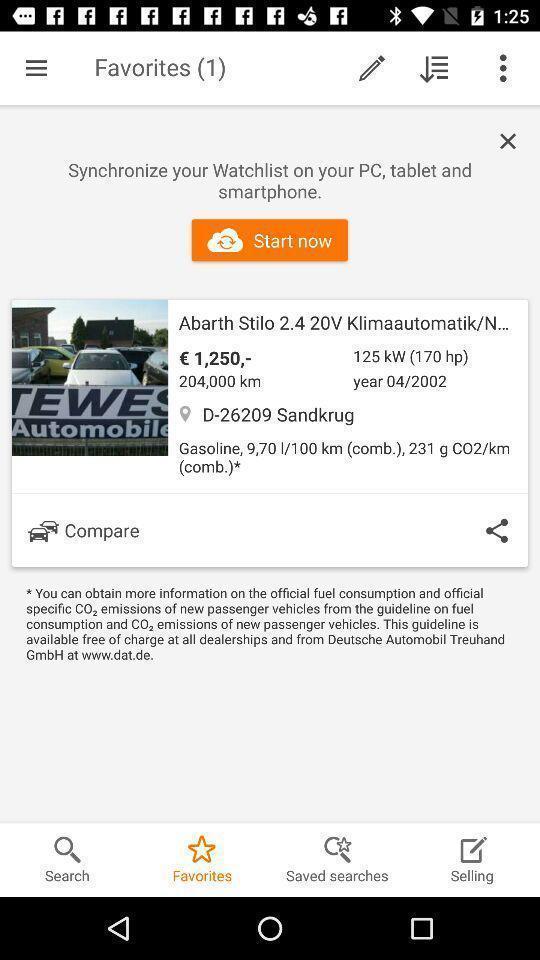Please provide a description for this image. Page showing list of favorites. 